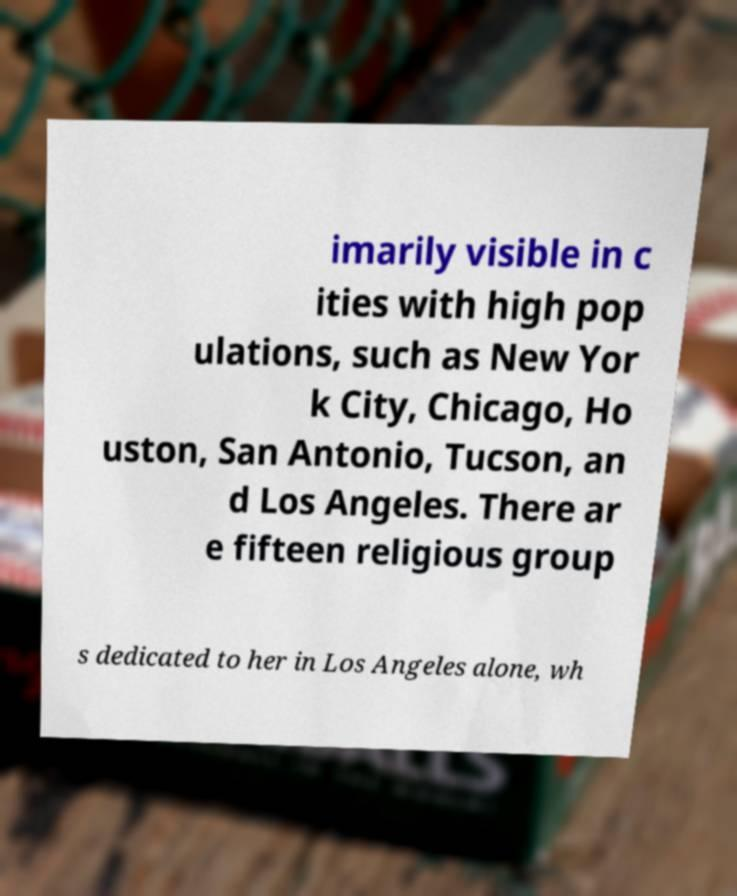I need the written content from this picture converted into text. Can you do that? imarily visible in c ities with high pop ulations, such as New Yor k City, Chicago, Ho uston, San Antonio, Tucson, an d Los Angeles. There ar e fifteen religious group s dedicated to her in Los Angeles alone, wh 